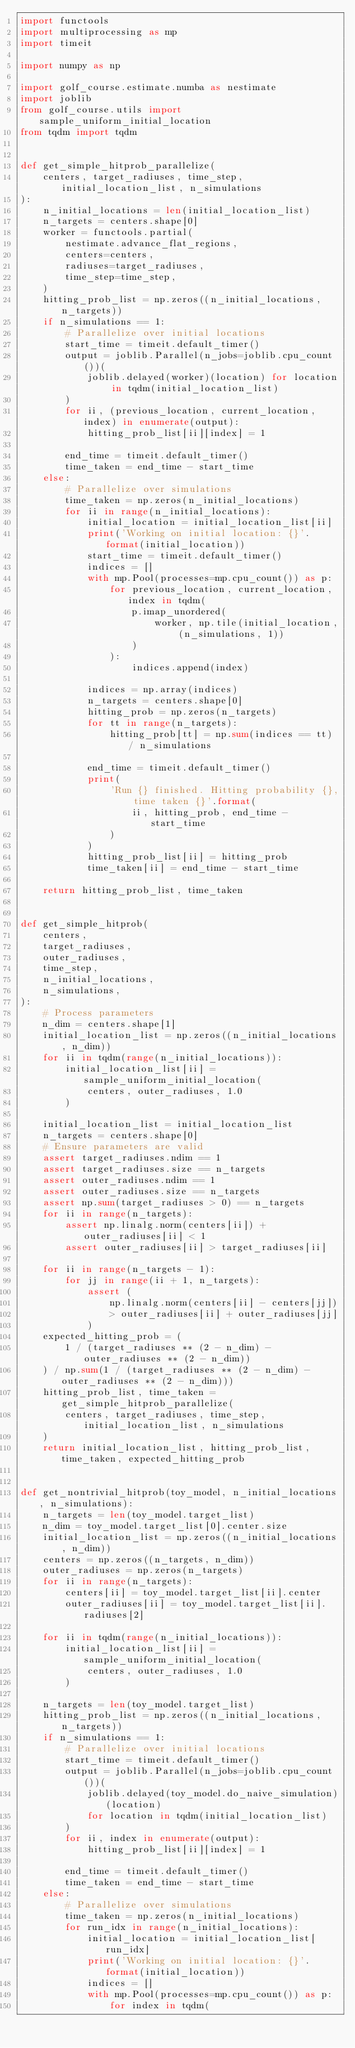Convert code to text. <code><loc_0><loc_0><loc_500><loc_500><_Python_>import functools
import multiprocessing as mp
import timeit

import numpy as np

import golf_course.estimate.numba as nestimate
import joblib
from golf_course.utils import sample_uniform_initial_location
from tqdm import tqdm


def get_simple_hitprob_parallelize(
    centers, target_radiuses, time_step, initial_location_list, n_simulations
):
    n_initial_locations = len(initial_location_list)
    n_targets = centers.shape[0]
    worker = functools.partial(
        nestimate.advance_flat_regions,
        centers=centers,
        radiuses=target_radiuses,
        time_step=time_step,
    )
    hitting_prob_list = np.zeros((n_initial_locations, n_targets))
    if n_simulations == 1:
        # Parallelize over initial locations
        start_time = timeit.default_timer()
        output = joblib.Parallel(n_jobs=joblib.cpu_count())(
            joblib.delayed(worker)(location) for location in tqdm(initial_location_list)
        )
        for ii, (previous_location, current_location, index) in enumerate(output):
            hitting_prob_list[ii][index] = 1

        end_time = timeit.default_timer()
        time_taken = end_time - start_time
    else:
        # Parallelize over simulations
        time_taken = np.zeros(n_initial_locations)
        for ii in range(n_initial_locations):
            initial_location = initial_location_list[ii]
            print('Working on initial location: {}'.format(initial_location))
            start_time = timeit.default_timer()
            indices = []
            with mp.Pool(processes=mp.cpu_count()) as p:
                for previous_location, current_location, index in tqdm(
                    p.imap_unordered(
                        worker, np.tile(initial_location, (n_simulations, 1))
                    )
                ):
                    indices.append(index)

            indices = np.array(indices)
            n_targets = centers.shape[0]
            hitting_prob = np.zeros(n_targets)
            for tt in range(n_targets):
                hitting_prob[tt] = np.sum(indices == tt) / n_simulations

            end_time = timeit.default_timer()
            print(
                'Run {} finished. Hitting probability {}, time taken {}'.format(
                    ii, hitting_prob, end_time - start_time
                )
            )
            hitting_prob_list[ii] = hitting_prob
            time_taken[ii] = end_time - start_time

    return hitting_prob_list, time_taken


def get_simple_hitprob(
    centers,
    target_radiuses,
    outer_radiuses,
    time_step,
    n_initial_locations,
    n_simulations,
):
    # Process parameters
    n_dim = centers.shape[1]
    initial_location_list = np.zeros((n_initial_locations, n_dim))
    for ii in tqdm(range(n_initial_locations)):
        initial_location_list[ii] = sample_uniform_initial_location(
            centers, outer_radiuses, 1.0
        )

    initial_location_list = initial_location_list
    n_targets = centers.shape[0]
    # Ensure parameters are valid
    assert target_radiuses.ndim == 1
    assert target_radiuses.size == n_targets
    assert outer_radiuses.ndim == 1
    assert outer_radiuses.size == n_targets
    assert np.sum(target_radiuses > 0) == n_targets
    for ii in range(n_targets):
        assert np.linalg.norm(centers[ii]) + outer_radiuses[ii] < 1
        assert outer_radiuses[ii] > target_radiuses[ii]

    for ii in range(n_targets - 1):
        for jj in range(ii + 1, n_targets):
            assert (
                np.linalg.norm(centers[ii] - centers[jj])
                > outer_radiuses[ii] + outer_radiuses[jj]
            )
    expected_hitting_prob = (
        1 / (target_radiuses ** (2 - n_dim) - outer_radiuses ** (2 - n_dim))
    ) / np.sum(1 / (target_radiuses ** (2 - n_dim) - outer_radiuses ** (2 - n_dim)))
    hitting_prob_list, time_taken = get_simple_hitprob_parallelize(
        centers, target_radiuses, time_step, initial_location_list, n_simulations
    )
    return initial_location_list, hitting_prob_list, time_taken, expected_hitting_prob


def get_nontrivial_hitprob(toy_model, n_initial_locations, n_simulations):
    n_targets = len(toy_model.target_list)
    n_dim = toy_model.target_list[0].center.size
    initial_location_list = np.zeros((n_initial_locations, n_dim))
    centers = np.zeros((n_targets, n_dim))
    outer_radiuses = np.zeros(n_targets)
    for ii in range(n_targets):
        centers[ii] = toy_model.target_list[ii].center
        outer_radiuses[ii] = toy_model.target_list[ii].radiuses[2]

    for ii in tqdm(range(n_initial_locations)):
        initial_location_list[ii] = sample_uniform_initial_location(
            centers, outer_radiuses, 1.0
        )

    n_targets = len(toy_model.target_list)
    hitting_prob_list = np.zeros((n_initial_locations, n_targets))
    if n_simulations == 1:
        # Parallelize over initial locations
        start_time = timeit.default_timer()
        output = joblib.Parallel(n_jobs=joblib.cpu_count())(
            joblib.delayed(toy_model.do_naive_simulation)(location)
            for location in tqdm(initial_location_list)
        )
        for ii, index in enumerate(output):
            hitting_prob_list[ii][index] = 1

        end_time = timeit.default_timer()
        time_taken = end_time - start_time
    else:
        # Parallelize over simulations
        time_taken = np.zeros(n_initial_locations)
        for run_idx in range(n_initial_locations):
            initial_location = initial_location_list[run_idx]
            print('Working on initial location: {}'.format(initial_location))
            indices = []
            with mp.Pool(processes=mp.cpu_count()) as p:
                for index in tqdm(</code> 